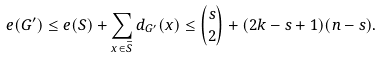Convert formula to latex. <formula><loc_0><loc_0><loc_500><loc_500>e ( G ^ { \prime } ) \leq e ( S ) + \sum _ { x \in \bar { S } } d _ { G ^ { \prime } } ( x ) \leq \binom { s } { 2 } + ( 2 k - s + 1 ) ( n - s ) .</formula> 